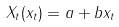<formula> <loc_0><loc_0><loc_500><loc_500>X _ { t } ( x _ { t } ) = a + b x _ { t }</formula> 